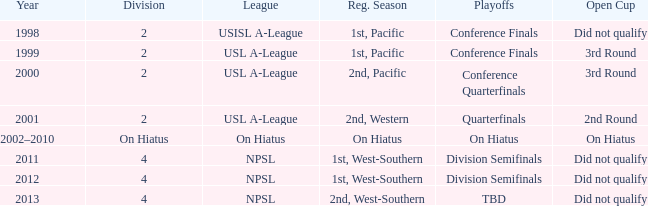In the usl a-league, when did the conference finals take place? 1999.0. 